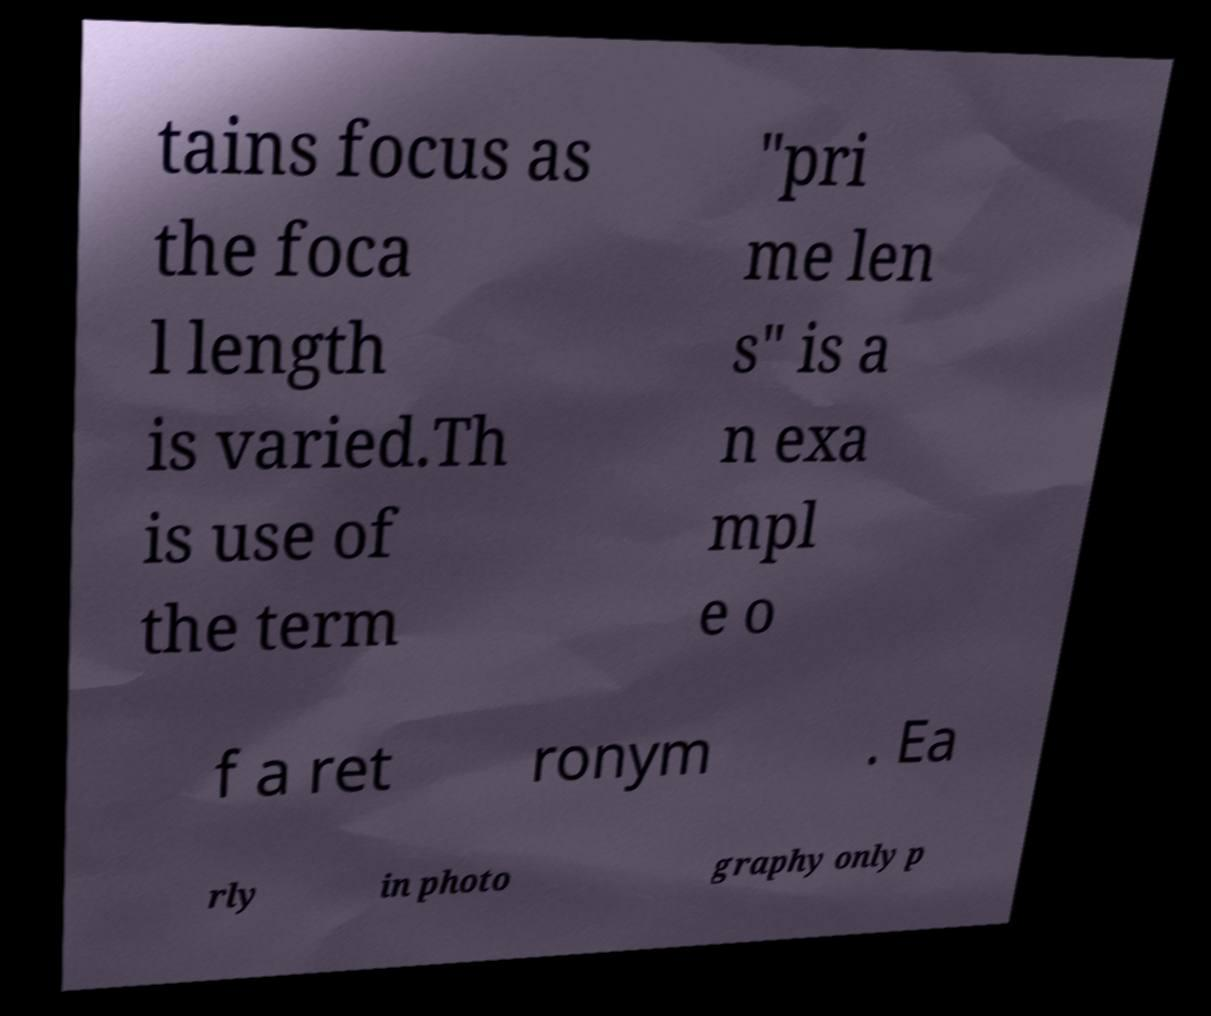I need the written content from this picture converted into text. Can you do that? tains focus as the foca l length is varied.Th is use of the term "pri me len s" is a n exa mpl e o f a ret ronym . Ea rly in photo graphy only p 